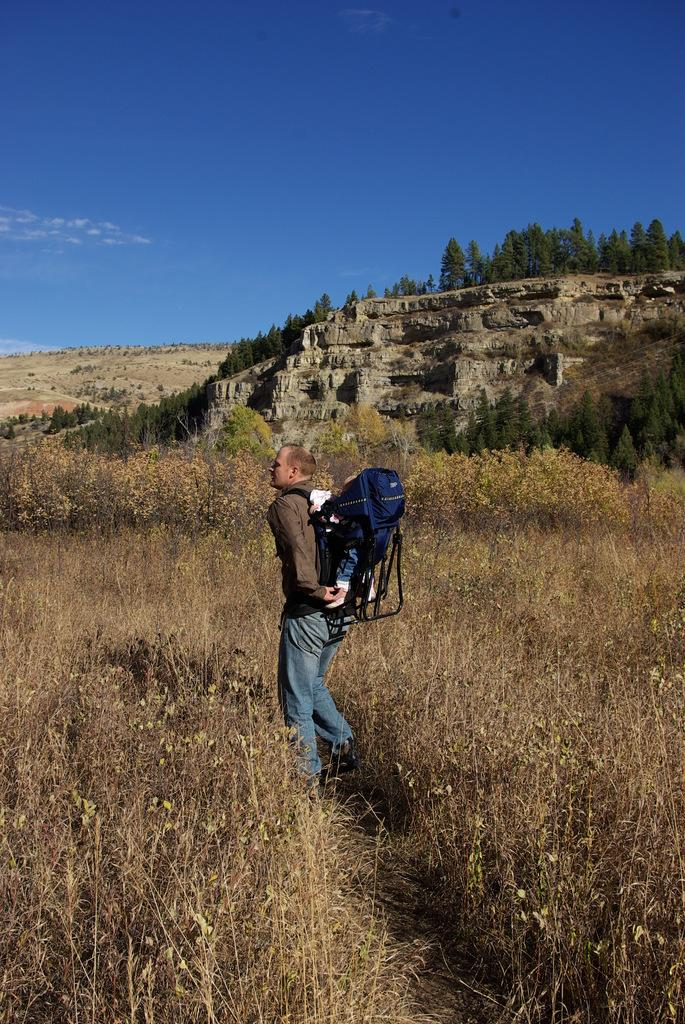What is the main subject in the foreground of the image? There is a man in the foreground of the image. What is the man wearing in the image? The man is wearing a bag in the image. What might be inside the bag the man is wearing? It appears that there is a baby in the bag. What type of natural environment can be seen in the image? There are plants, trees, and a cliff visible in the image. What parts of the natural environment are visible in the image? Land and the sky are visible in the image. What type of kite is being flown by the man in the image? There is no kite present in the image; the man is wearing a bag with a baby inside. 